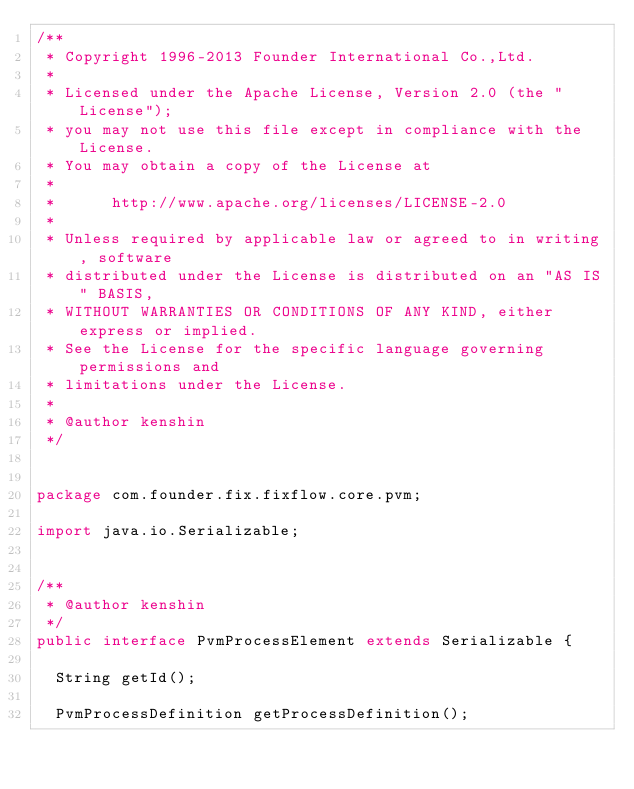Convert code to text. <code><loc_0><loc_0><loc_500><loc_500><_Java_>/**
 * Copyright 1996-2013 Founder International Co.,Ltd.
 *
 * Licensed under the Apache License, Version 2.0 (the "License");
 * you may not use this file except in compliance with the License.
 * You may obtain a copy of the License at
 * 
 *      http://www.apache.org/licenses/LICENSE-2.0
 * 
 * Unless required by applicable law or agreed to in writing, software
 * distributed under the License is distributed on an "AS IS" BASIS,
 * WITHOUT WARRANTIES OR CONDITIONS OF ANY KIND, either express or implied.
 * See the License for the specific language governing permissions and
 * limitations under the License.
 * 
 * @author kenshin
 */


package com.founder.fix.fixflow.core.pvm;

import java.io.Serializable;


/**
 * @author kenshin
 */
public interface PvmProcessElement extends Serializable {

  String getId();
  
  PvmProcessDefinition getProcessDefinition();
  </code> 